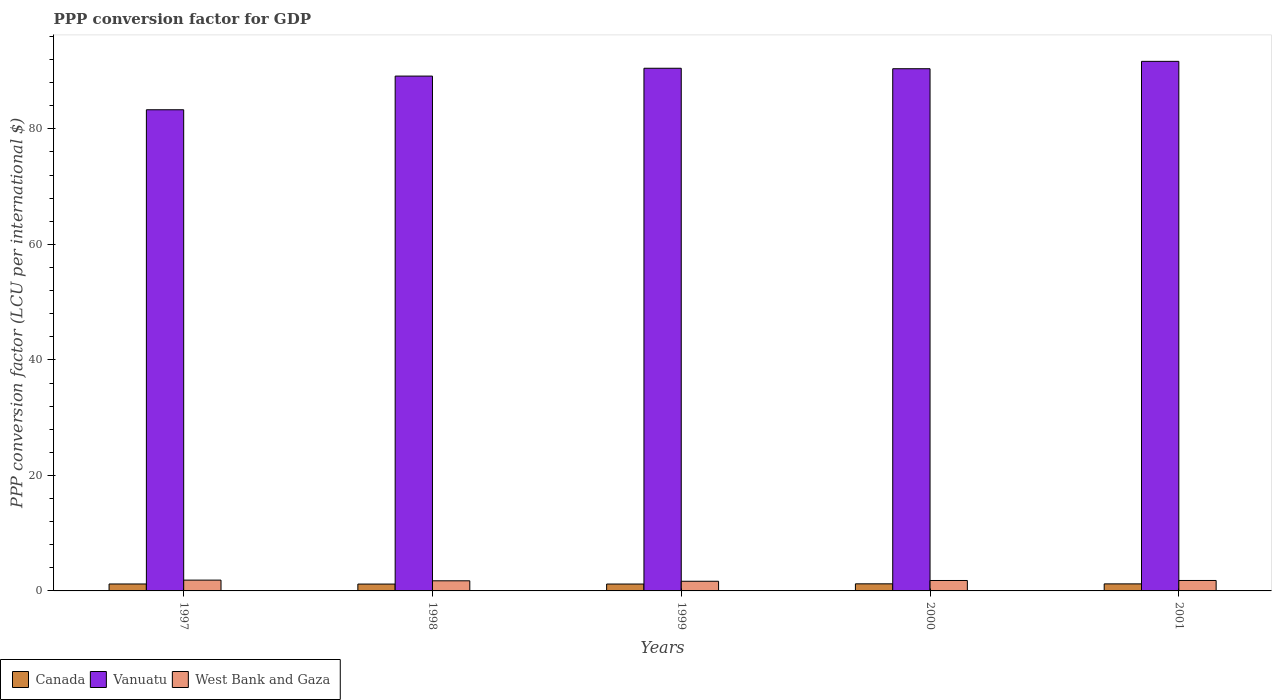How many bars are there on the 3rd tick from the left?
Offer a terse response. 3. In how many cases, is the number of bars for a given year not equal to the number of legend labels?
Your answer should be very brief. 0. What is the PPP conversion factor for GDP in Vanuatu in 2001?
Keep it short and to the point. 91.7. Across all years, what is the maximum PPP conversion factor for GDP in West Bank and Gaza?
Give a very brief answer. 1.87. Across all years, what is the minimum PPP conversion factor for GDP in Vanuatu?
Give a very brief answer. 83.31. What is the total PPP conversion factor for GDP in Canada in the graph?
Your answer should be compact. 6.03. What is the difference between the PPP conversion factor for GDP in Canada in 1999 and that in 2001?
Keep it short and to the point. -0.03. What is the difference between the PPP conversion factor for GDP in West Bank and Gaza in 2000 and the PPP conversion factor for GDP in Vanuatu in 1997?
Provide a short and direct response. -81.51. What is the average PPP conversion factor for GDP in West Bank and Gaza per year?
Your response must be concise. 1.78. In the year 1999, what is the difference between the PPP conversion factor for GDP in Vanuatu and PPP conversion factor for GDP in Canada?
Your answer should be very brief. 89.31. In how many years, is the PPP conversion factor for GDP in Vanuatu greater than 76 LCU?
Your answer should be very brief. 5. What is the ratio of the PPP conversion factor for GDP in West Bank and Gaza in 1999 to that in 2001?
Provide a succinct answer. 0.93. Is the difference between the PPP conversion factor for GDP in Vanuatu in 1999 and 2000 greater than the difference between the PPP conversion factor for GDP in Canada in 1999 and 2000?
Keep it short and to the point. Yes. What is the difference between the highest and the second highest PPP conversion factor for GDP in Canada?
Provide a short and direct response. 0.01. What is the difference between the highest and the lowest PPP conversion factor for GDP in Canada?
Your answer should be compact. 0.04. In how many years, is the PPP conversion factor for GDP in Canada greater than the average PPP conversion factor for GDP in Canada taken over all years?
Give a very brief answer. 2. Is it the case that in every year, the sum of the PPP conversion factor for GDP in Vanuatu and PPP conversion factor for GDP in West Bank and Gaza is greater than the PPP conversion factor for GDP in Canada?
Ensure brevity in your answer.  Yes. How many bars are there?
Provide a short and direct response. 15. What is the difference between two consecutive major ticks on the Y-axis?
Provide a succinct answer. 20. Where does the legend appear in the graph?
Offer a very short reply. Bottom left. How many legend labels are there?
Make the answer very short. 3. What is the title of the graph?
Give a very brief answer. PPP conversion factor for GDP. Does "Jamaica" appear as one of the legend labels in the graph?
Your answer should be compact. No. What is the label or title of the Y-axis?
Your answer should be compact. PPP conversion factor (LCU per international $). What is the PPP conversion factor (LCU per international $) of Canada in 1997?
Make the answer very short. 1.2. What is the PPP conversion factor (LCU per international $) in Vanuatu in 1997?
Provide a short and direct response. 83.31. What is the PPP conversion factor (LCU per international $) of West Bank and Gaza in 1997?
Provide a short and direct response. 1.87. What is the PPP conversion factor (LCU per international $) of Canada in 1998?
Your response must be concise. 1.19. What is the PPP conversion factor (LCU per international $) in Vanuatu in 1998?
Offer a very short reply. 89.14. What is the PPP conversion factor (LCU per international $) in West Bank and Gaza in 1998?
Offer a very short reply. 1.75. What is the PPP conversion factor (LCU per international $) in Canada in 1999?
Your answer should be compact. 1.19. What is the PPP conversion factor (LCU per international $) in Vanuatu in 1999?
Offer a terse response. 90.5. What is the PPP conversion factor (LCU per international $) of West Bank and Gaza in 1999?
Offer a terse response. 1.67. What is the PPP conversion factor (LCU per international $) of Canada in 2000?
Your response must be concise. 1.23. What is the PPP conversion factor (LCU per international $) of Vanuatu in 2000?
Keep it short and to the point. 90.42. What is the PPP conversion factor (LCU per international $) of West Bank and Gaza in 2000?
Offer a very short reply. 1.81. What is the PPP conversion factor (LCU per international $) of Canada in 2001?
Make the answer very short. 1.22. What is the PPP conversion factor (LCU per international $) of Vanuatu in 2001?
Your response must be concise. 91.7. What is the PPP conversion factor (LCU per international $) in West Bank and Gaza in 2001?
Give a very brief answer. 1.81. Across all years, what is the maximum PPP conversion factor (LCU per international $) of Canada?
Provide a short and direct response. 1.23. Across all years, what is the maximum PPP conversion factor (LCU per international $) in Vanuatu?
Give a very brief answer. 91.7. Across all years, what is the maximum PPP conversion factor (LCU per international $) in West Bank and Gaza?
Offer a very short reply. 1.87. Across all years, what is the minimum PPP conversion factor (LCU per international $) in Canada?
Keep it short and to the point. 1.19. Across all years, what is the minimum PPP conversion factor (LCU per international $) in Vanuatu?
Provide a succinct answer. 83.31. Across all years, what is the minimum PPP conversion factor (LCU per international $) in West Bank and Gaza?
Your response must be concise. 1.67. What is the total PPP conversion factor (LCU per international $) in Canada in the graph?
Your answer should be very brief. 6.03. What is the total PPP conversion factor (LCU per international $) of Vanuatu in the graph?
Give a very brief answer. 445.07. What is the total PPP conversion factor (LCU per international $) in West Bank and Gaza in the graph?
Make the answer very short. 8.91. What is the difference between the PPP conversion factor (LCU per international $) in Canada in 1997 and that in 1998?
Make the answer very short. 0.02. What is the difference between the PPP conversion factor (LCU per international $) in Vanuatu in 1997 and that in 1998?
Offer a terse response. -5.83. What is the difference between the PPP conversion factor (LCU per international $) of West Bank and Gaza in 1997 and that in 1998?
Offer a terse response. 0.12. What is the difference between the PPP conversion factor (LCU per international $) in Canada in 1997 and that in 1999?
Provide a succinct answer. 0.01. What is the difference between the PPP conversion factor (LCU per international $) of Vanuatu in 1997 and that in 1999?
Provide a succinct answer. -7.18. What is the difference between the PPP conversion factor (LCU per international $) of West Bank and Gaza in 1997 and that in 1999?
Make the answer very short. 0.2. What is the difference between the PPP conversion factor (LCU per international $) of Canada in 1997 and that in 2000?
Your answer should be compact. -0.03. What is the difference between the PPP conversion factor (LCU per international $) in Vanuatu in 1997 and that in 2000?
Offer a very short reply. -7.1. What is the difference between the PPP conversion factor (LCU per international $) of West Bank and Gaza in 1997 and that in 2000?
Provide a short and direct response. 0.06. What is the difference between the PPP conversion factor (LCU per international $) of Canada in 1997 and that in 2001?
Offer a terse response. -0.02. What is the difference between the PPP conversion factor (LCU per international $) in Vanuatu in 1997 and that in 2001?
Provide a succinct answer. -8.38. What is the difference between the PPP conversion factor (LCU per international $) of West Bank and Gaza in 1997 and that in 2001?
Your answer should be compact. 0.06. What is the difference between the PPP conversion factor (LCU per international $) of Canada in 1998 and that in 1999?
Your answer should be compact. -0. What is the difference between the PPP conversion factor (LCU per international $) of Vanuatu in 1998 and that in 1999?
Your response must be concise. -1.36. What is the difference between the PPP conversion factor (LCU per international $) in West Bank and Gaza in 1998 and that in 1999?
Offer a terse response. 0.08. What is the difference between the PPP conversion factor (LCU per international $) in Canada in 1998 and that in 2000?
Ensure brevity in your answer.  -0.04. What is the difference between the PPP conversion factor (LCU per international $) in Vanuatu in 1998 and that in 2000?
Your response must be concise. -1.28. What is the difference between the PPP conversion factor (LCU per international $) in West Bank and Gaza in 1998 and that in 2000?
Your answer should be compact. -0.05. What is the difference between the PPP conversion factor (LCU per international $) in Canada in 1998 and that in 2001?
Make the answer very short. -0.03. What is the difference between the PPP conversion factor (LCU per international $) of Vanuatu in 1998 and that in 2001?
Provide a short and direct response. -2.55. What is the difference between the PPP conversion factor (LCU per international $) of West Bank and Gaza in 1998 and that in 2001?
Your answer should be very brief. -0.06. What is the difference between the PPP conversion factor (LCU per international $) in Canada in 1999 and that in 2000?
Your answer should be compact. -0.04. What is the difference between the PPP conversion factor (LCU per international $) of Vanuatu in 1999 and that in 2000?
Offer a very short reply. 0.08. What is the difference between the PPP conversion factor (LCU per international $) in West Bank and Gaza in 1999 and that in 2000?
Provide a succinct answer. -0.13. What is the difference between the PPP conversion factor (LCU per international $) in Canada in 1999 and that in 2001?
Your answer should be very brief. -0.03. What is the difference between the PPP conversion factor (LCU per international $) in Vanuatu in 1999 and that in 2001?
Your answer should be very brief. -1.2. What is the difference between the PPP conversion factor (LCU per international $) of West Bank and Gaza in 1999 and that in 2001?
Provide a succinct answer. -0.13. What is the difference between the PPP conversion factor (LCU per international $) of Canada in 2000 and that in 2001?
Your answer should be compact. 0.01. What is the difference between the PPP conversion factor (LCU per international $) of Vanuatu in 2000 and that in 2001?
Your response must be concise. -1.28. What is the difference between the PPP conversion factor (LCU per international $) in West Bank and Gaza in 2000 and that in 2001?
Provide a short and direct response. -0. What is the difference between the PPP conversion factor (LCU per international $) of Canada in 1997 and the PPP conversion factor (LCU per international $) of Vanuatu in 1998?
Ensure brevity in your answer.  -87.94. What is the difference between the PPP conversion factor (LCU per international $) of Canada in 1997 and the PPP conversion factor (LCU per international $) of West Bank and Gaza in 1998?
Your answer should be very brief. -0.55. What is the difference between the PPP conversion factor (LCU per international $) of Vanuatu in 1997 and the PPP conversion factor (LCU per international $) of West Bank and Gaza in 1998?
Offer a very short reply. 81.56. What is the difference between the PPP conversion factor (LCU per international $) in Canada in 1997 and the PPP conversion factor (LCU per international $) in Vanuatu in 1999?
Offer a terse response. -89.3. What is the difference between the PPP conversion factor (LCU per international $) of Canada in 1997 and the PPP conversion factor (LCU per international $) of West Bank and Gaza in 1999?
Give a very brief answer. -0.47. What is the difference between the PPP conversion factor (LCU per international $) in Vanuatu in 1997 and the PPP conversion factor (LCU per international $) in West Bank and Gaza in 1999?
Keep it short and to the point. 81.64. What is the difference between the PPP conversion factor (LCU per international $) in Canada in 1997 and the PPP conversion factor (LCU per international $) in Vanuatu in 2000?
Your response must be concise. -89.22. What is the difference between the PPP conversion factor (LCU per international $) in Canada in 1997 and the PPP conversion factor (LCU per international $) in West Bank and Gaza in 2000?
Offer a very short reply. -0.6. What is the difference between the PPP conversion factor (LCU per international $) in Vanuatu in 1997 and the PPP conversion factor (LCU per international $) in West Bank and Gaza in 2000?
Your answer should be compact. 81.51. What is the difference between the PPP conversion factor (LCU per international $) in Canada in 1997 and the PPP conversion factor (LCU per international $) in Vanuatu in 2001?
Your answer should be very brief. -90.49. What is the difference between the PPP conversion factor (LCU per international $) in Canada in 1997 and the PPP conversion factor (LCU per international $) in West Bank and Gaza in 2001?
Provide a short and direct response. -0.61. What is the difference between the PPP conversion factor (LCU per international $) of Vanuatu in 1997 and the PPP conversion factor (LCU per international $) of West Bank and Gaza in 2001?
Provide a short and direct response. 81.51. What is the difference between the PPP conversion factor (LCU per international $) of Canada in 1998 and the PPP conversion factor (LCU per international $) of Vanuatu in 1999?
Your answer should be very brief. -89.31. What is the difference between the PPP conversion factor (LCU per international $) of Canada in 1998 and the PPP conversion factor (LCU per international $) of West Bank and Gaza in 1999?
Provide a short and direct response. -0.49. What is the difference between the PPP conversion factor (LCU per international $) of Vanuatu in 1998 and the PPP conversion factor (LCU per international $) of West Bank and Gaza in 1999?
Give a very brief answer. 87.47. What is the difference between the PPP conversion factor (LCU per international $) in Canada in 1998 and the PPP conversion factor (LCU per international $) in Vanuatu in 2000?
Offer a very short reply. -89.23. What is the difference between the PPP conversion factor (LCU per international $) in Canada in 1998 and the PPP conversion factor (LCU per international $) in West Bank and Gaza in 2000?
Ensure brevity in your answer.  -0.62. What is the difference between the PPP conversion factor (LCU per international $) in Vanuatu in 1998 and the PPP conversion factor (LCU per international $) in West Bank and Gaza in 2000?
Provide a short and direct response. 87.34. What is the difference between the PPP conversion factor (LCU per international $) in Canada in 1998 and the PPP conversion factor (LCU per international $) in Vanuatu in 2001?
Offer a very short reply. -90.51. What is the difference between the PPP conversion factor (LCU per international $) of Canada in 1998 and the PPP conversion factor (LCU per international $) of West Bank and Gaza in 2001?
Offer a very short reply. -0.62. What is the difference between the PPP conversion factor (LCU per international $) in Vanuatu in 1998 and the PPP conversion factor (LCU per international $) in West Bank and Gaza in 2001?
Your response must be concise. 87.34. What is the difference between the PPP conversion factor (LCU per international $) of Canada in 1999 and the PPP conversion factor (LCU per international $) of Vanuatu in 2000?
Keep it short and to the point. -89.23. What is the difference between the PPP conversion factor (LCU per international $) of Canada in 1999 and the PPP conversion factor (LCU per international $) of West Bank and Gaza in 2000?
Keep it short and to the point. -0.62. What is the difference between the PPP conversion factor (LCU per international $) in Vanuatu in 1999 and the PPP conversion factor (LCU per international $) in West Bank and Gaza in 2000?
Give a very brief answer. 88.69. What is the difference between the PPP conversion factor (LCU per international $) in Canada in 1999 and the PPP conversion factor (LCU per international $) in Vanuatu in 2001?
Provide a succinct answer. -90.5. What is the difference between the PPP conversion factor (LCU per international $) in Canada in 1999 and the PPP conversion factor (LCU per international $) in West Bank and Gaza in 2001?
Offer a terse response. -0.62. What is the difference between the PPP conversion factor (LCU per international $) in Vanuatu in 1999 and the PPP conversion factor (LCU per international $) in West Bank and Gaza in 2001?
Offer a very short reply. 88.69. What is the difference between the PPP conversion factor (LCU per international $) in Canada in 2000 and the PPP conversion factor (LCU per international $) in Vanuatu in 2001?
Offer a terse response. -90.47. What is the difference between the PPP conversion factor (LCU per international $) of Canada in 2000 and the PPP conversion factor (LCU per international $) of West Bank and Gaza in 2001?
Give a very brief answer. -0.58. What is the difference between the PPP conversion factor (LCU per international $) in Vanuatu in 2000 and the PPP conversion factor (LCU per international $) in West Bank and Gaza in 2001?
Your answer should be very brief. 88.61. What is the average PPP conversion factor (LCU per international $) of Canada per year?
Ensure brevity in your answer.  1.21. What is the average PPP conversion factor (LCU per international $) of Vanuatu per year?
Ensure brevity in your answer.  89.01. What is the average PPP conversion factor (LCU per international $) in West Bank and Gaza per year?
Offer a terse response. 1.78. In the year 1997, what is the difference between the PPP conversion factor (LCU per international $) in Canada and PPP conversion factor (LCU per international $) in Vanuatu?
Offer a terse response. -82.11. In the year 1997, what is the difference between the PPP conversion factor (LCU per international $) in Canada and PPP conversion factor (LCU per international $) in West Bank and Gaza?
Give a very brief answer. -0.67. In the year 1997, what is the difference between the PPP conversion factor (LCU per international $) of Vanuatu and PPP conversion factor (LCU per international $) of West Bank and Gaza?
Provide a short and direct response. 81.44. In the year 1998, what is the difference between the PPP conversion factor (LCU per international $) of Canada and PPP conversion factor (LCU per international $) of Vanuatu?
Your response must be concise. -87.96. In the year 1998, what is the difference between the PPP conversion factor (LCU per international $) of Canada and PPP conversion factor (LCU per international $) of West Bank and Gaza?
Make the answer very short. -0.56. In the year 1998, what is the difference between the PPP conversion factor (LCU per international $) of Vanuatu and PPP conversion factor (LCU per international $) of West Bank and Gaza?
Your response must be concise. 87.39. In the year 1999, what is the difference between the PPP conversion factor (LCU per international $) in Canada and PPP conversion factor (LCU per international $) in Vanuatu?
Keep it short and to the point. -89.31. In the year 1999, what is the difference between the PPP conversion factor (LCU per international $) in Canada and PPP conversion factor (LCU per international $) in West Bank and Gaza?
Offer a terse response. -0.48. In the year 1999, what is the difference between the PPP conversion factor (LCU per international $) of Vanuatu and PPP conversion factor (LCU per international $) of West Bank and Gaza?
Provide a succinct answer. 88.83. In the year 2000, what is the difference between the PPP conversion factor (LCU per international $) of Canada and PPP conversion factor (LCU per international $) of Vanuatu?
Offer a terse response. -89.19. In the year 2000, what is the difference between the PPP conversion factor (LCU per international $) of Canada and PPP conversion factor (LCU per international $) of West Bank and Gaza?
Make the answer very short. -0.58. In the year 2000, what is the difference between the PPP conversion factor (LCU per international $) of Vanuatu and PPP conversion factor (LCU per international $) of West Bank and Gaza?
Offer a terse response. 88.61. In the year 2001, what is the difference between the PPP conversion factor (LCU per international $) of Canada and PPP conversion factor (LCU per international $) of Vanuatu?
Provide a short and direct response. -90.48. In the year 2001, what is the difference between the PPP conversion factor (LCU per international $) in Canada and PPP conversion factor (LCU per international $) in West Bank and Gaza?
Your response must be concise. -0.59. In the year 2001, what is the difference between the PPP conversion factor (LCU per international $) of Vanuatu and PPP conversion factor (LCU per international $) of West Bank and Gaza?
Your response must be concise. 89.89. What is the ratio of the PPP conversion factor (LCU per international $) in Canada in 1997 to that in 1998?
Keep it short and to the point. 1.01. What is the ratio of the PPP conversion factor (LCU per international $) in Vanuatu in 1997 to that in 1998?
Offer a terse response. 0.93. What is the ratio of the PPP conversion factor (LCU per international $) in West Bank and Gaza in 1997 to that in 1998?
Offer a very short reply. 1.07. What is the ratio of the PPP conversion factor (LCU per international $) in Canada in 1997 to that in 1999?
Offer a very short reply. 1.01. What is the ratio of the PPP conversion factor (LCU per international $) of Vanuatu in 1997 to that in 1999?
Ensure brevity in your answer.  0.92. What is the ratio of the PPP conversion factor (LCU per international $) in West Bank and Gaza in 1997 to that in 1999?
Your response must be concise. 1.12. What is the ratio of the PPP conversion factor (LCU per international $) in Canada in 1997 to that in 2000?
Keep it short and to the point. 0.98. What is the ratio of the PPP conversion factor (LCU per international $) in Vanuatu in 1997 to that in 2000?
Your answer should be very brief. 0.92. What is the ratio of the PPP conversion factor (LCU per international $) in West Bank and Gaza in 1997 to that in 2000?
Keep it short and to the point. 1.04. What is the ratio of the PPP conversion factor (LCU per international $) in Canada in 1997 to that in 2001?
Offer a terse response. 0.99. What is the ratio of the PPP conversion factor (LCU per international $) in Vanuatu in 1997 to that in 2001?
Your answer should be very brief. 0.91. What is the ratio of the PPP conversion factor (LCU per international $) of West Bank and Gaza in 1997 to that in 2001?
Your answer should be compact. 1.04. What is the ratio of the PPP conversion factor (LCU per international $) in West Bank and Gaza in 1998 to that in 1999?
Ensure brevity in your answer.  1.05. What is the ratio of the PPP conversion factor (LCU per international $) in Vanuatu in 1998 to that in 2000?
Your response must be concise. 0.99. What is the ratio of the PPP conversion factor (LCU per international $) in West Bank and Gaza in 1998 to that in 2000?
Give a very brief answer. 0.97. What is the ratio of the PPP conversion factor (LCU per international $) of Canada in 1998 to that in 2001?
Make the answer very short. 0.97. What is the ratio of the PPP conversion factor (LCU per international $) of Vanuatu in 1998 to that in 2001?
Provide a succinct answer. 0.97. What is the ratio of the PPP conversion factor (LCU per international $) of West Bank and Gaza in 1998 to that in 2001?
Give a very brief answer. 0.97. What is the ratio of the PPP conversion factor (LCU per international $) in Canada in 1999 to that in 2000?
Your answer should be very brief. 0.97. What is the ratio of the PPP conversion factor (LCU per international $) of West Bank and Gaza in 1999 to that in 2000?
Your answer should be compact. 0.93. What is the ratio of the PPP conversion factor (LCU per international $) in Canada in 1999 to that in 2001?
Make the answer very short. 0.98. What is the ratio of the PPP conversion factor (LCU per international $) of Vanuatu in 1999 to that in 2001?
Your response must be concise. 0.99. What is the ratio of the PPP conversion factor (LCU per international $) of West Bank and Gaza in 1999 to that in 2001?
Your answer should be compact. 0.93. What is the ratio of the PPP conversion factor (LCU per international $) in Vanuatu in 2000 to that in 2001?
Give a very brief answer. 0.99. What is the ratio of the PPP conversion factor (LCU per international $) in West Bank and Gaza in 2000 to that in 2001?
Offer a terse response. 1. What is the difference between the highest and the second highest PPP conversion factor (LCU per international $) of Canada?
Offer a very short reply. 0.01. What is the difference between the highest and the second highest PPP conversion factor (LCU per international $) of Vanuatu?
Your answer should be compact. 1.2. What is the difference between the highest and the second highest PPP conversion factor (LCU per international $) in West Bank and Gaza?
Offer a very short reply. 0.06. What is the difference between the highest and the lowest PPP conversion factor (LCU per international $) in Canada?
Make the answer very short. 0.04. What is the difference between the highest and the lowest PPP conversion factor (LCU per international $) in Vanuatu?
Your answer should be compact. 8.38. What is the difference between the highest and the lowest PPP conversion factor (LCU per international $) in West Bank and Gaza?
Give a very brief answer. 0.2. 